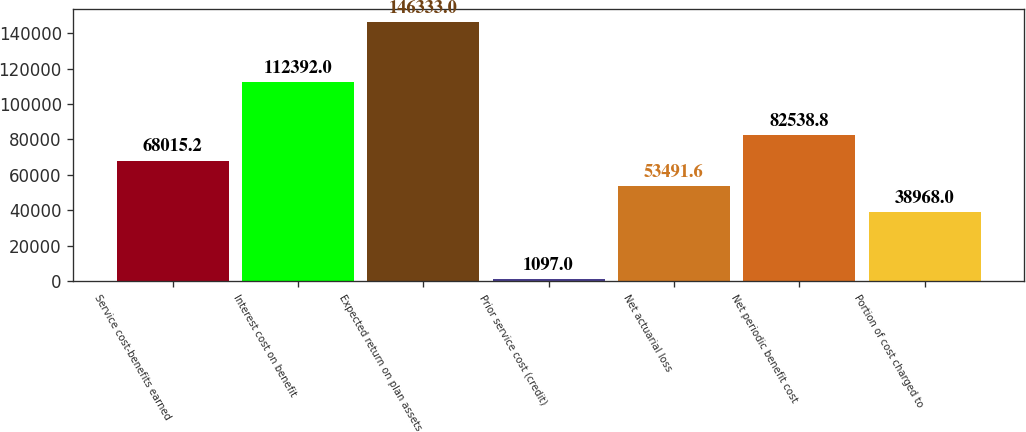Convert chart. <chart><loc_0><loc_0><loc_500><loc_500><bar_chart><fcel>Service cost-benefits earned<fcel>Interest cost on benefit<fcel>Expected return on plan assets<fcel>Prior service cost (credit)<fcel>Net actuarial loss<fcel>Net periodic benefit cost<fcel>Portion of cost charged to<nl><fcel>68015.2<fcel>112392<fcel>146333<fcel>1097<fcel>53491.6<fcel>82538.8<fcel>38968<nl></chart> 